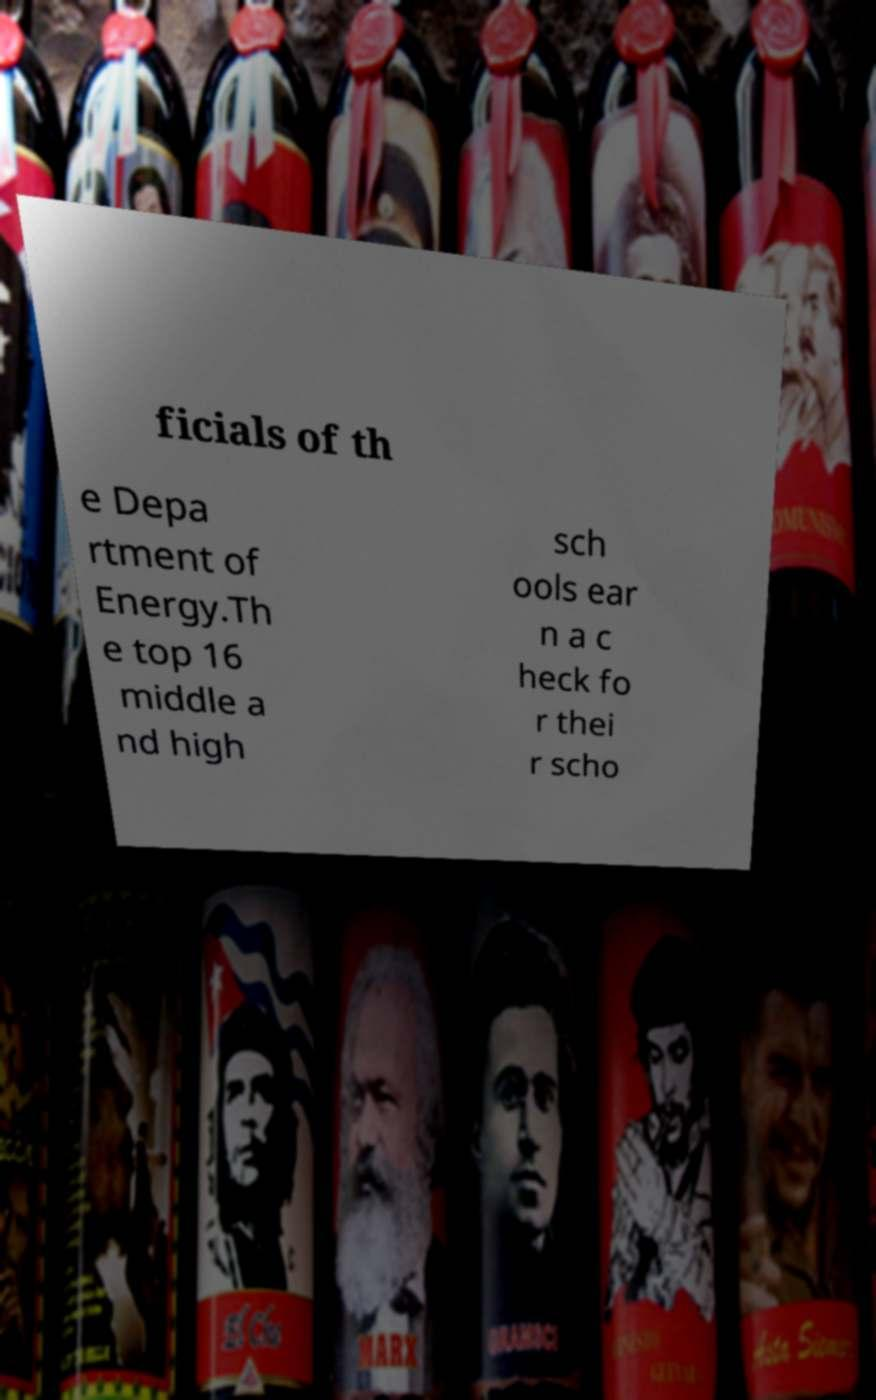What messages or text are displayed in this image? I need them in a readable, typed format. ficials of th e Depa rtment of Energy.Th e top 16 middle a nd high sch ools ear n a c heck fo r thei r scho 